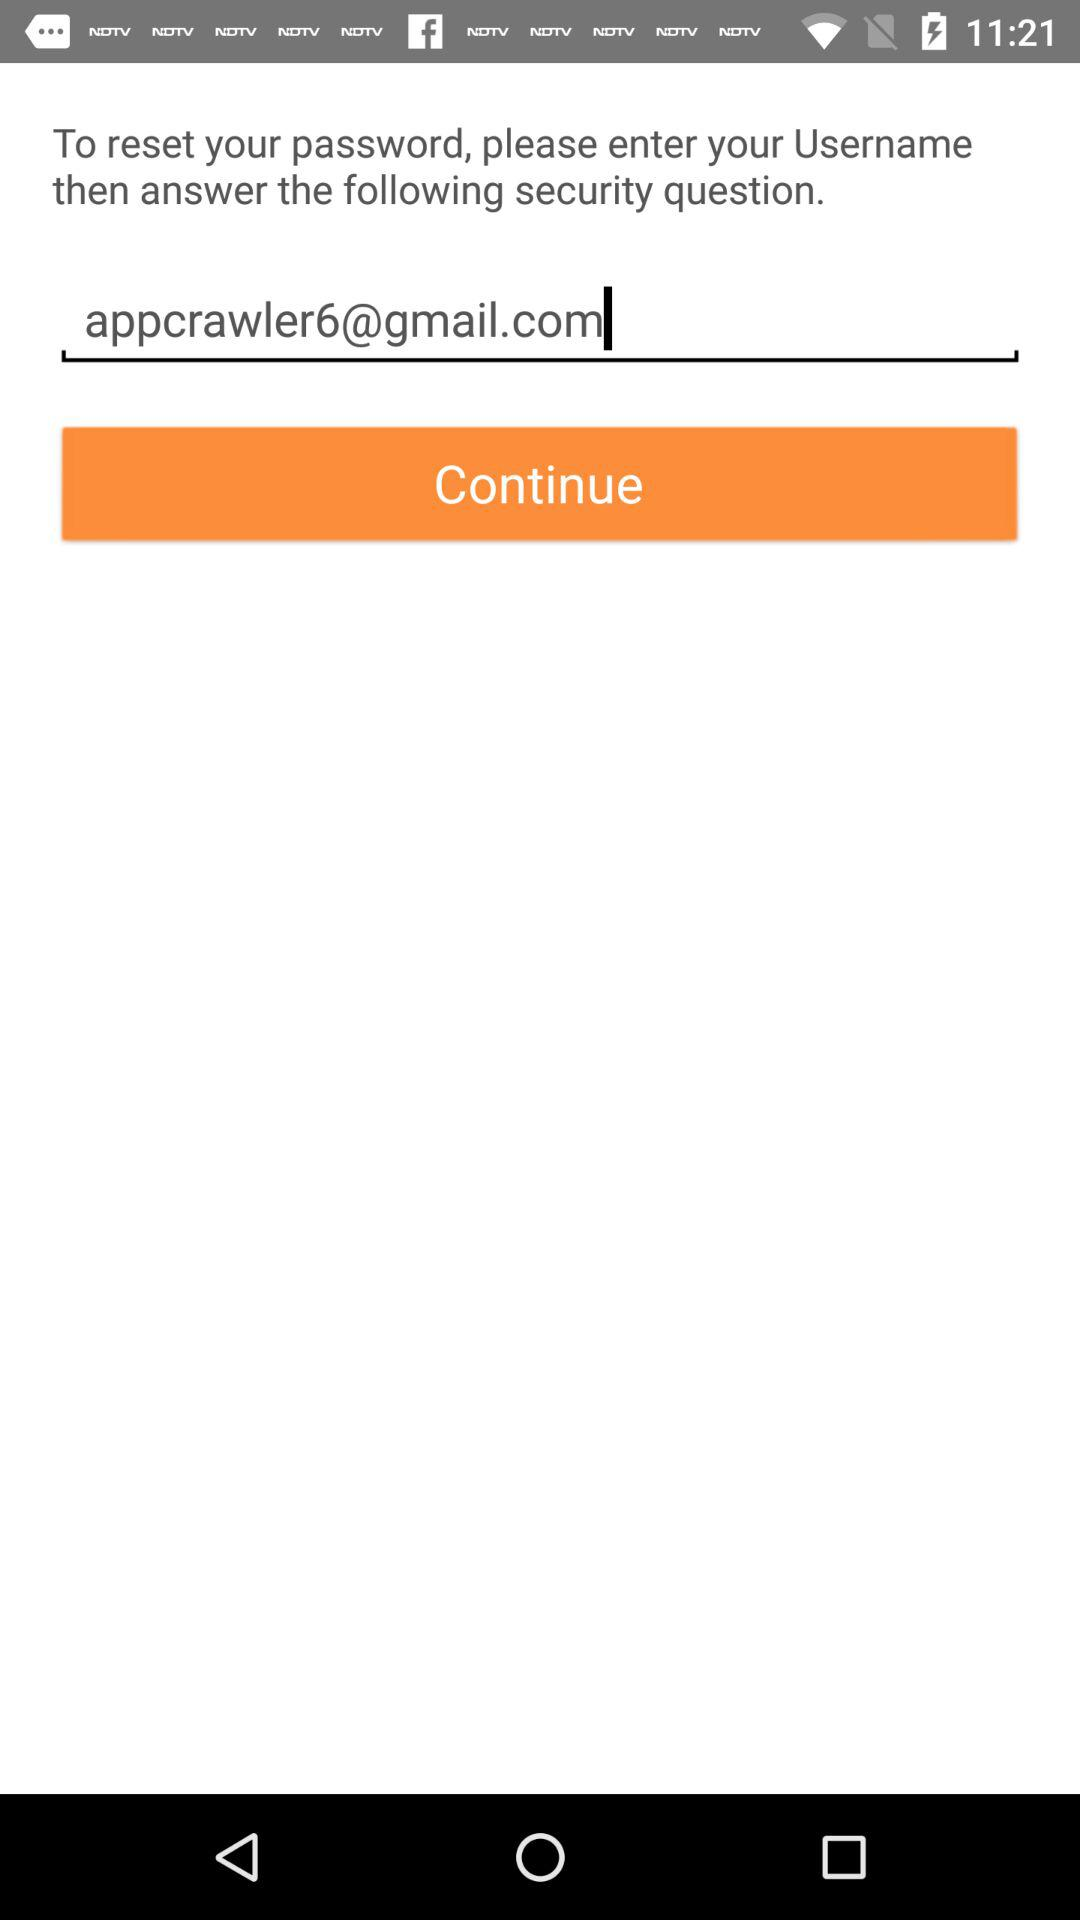What is the entered email address? The entered email address is appcrawler6@gmail.com. 